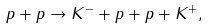Convert formula to latex. <formula><loc_0><loc_0><loc_500><loc_500>p + p \rightarrow K ^ { - } + p + p + K ^ { + } ,</formula> 